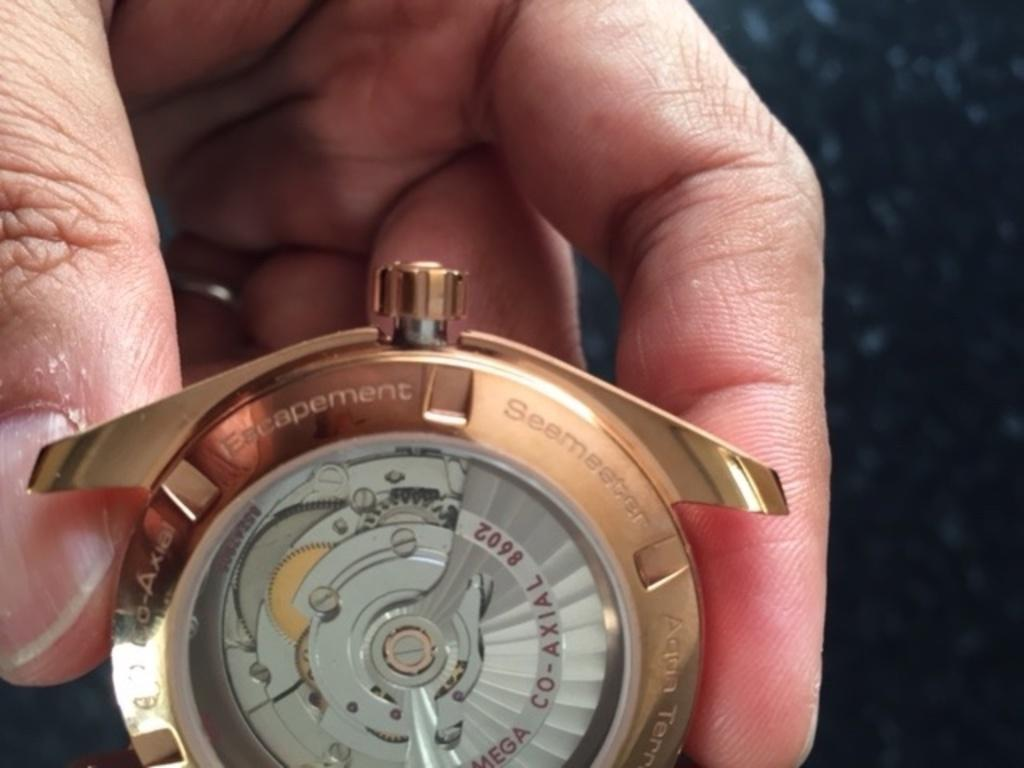<image>
Relay a brief, clear account of the picture shown. A THREE TONED GOLD AND SILVER  CO AXIAL WATCH 